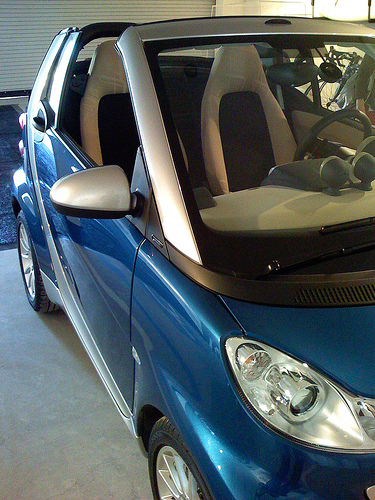<image>
Is there a car above the floor? No. The car is not positioned above the floor. The vertical arrangement shows a different relationship. 